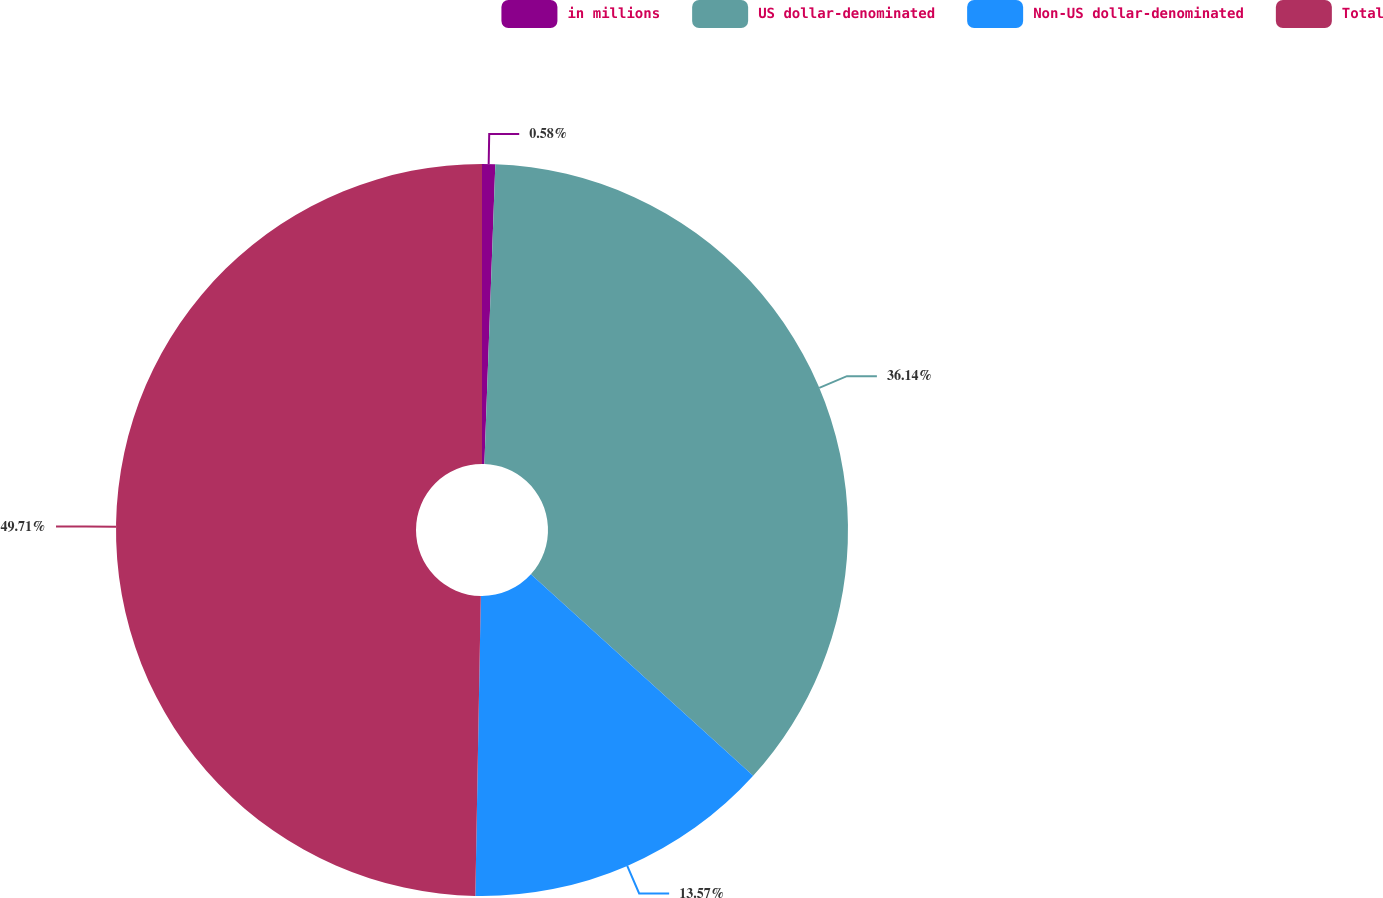Convert chart to OTSL. <chart><loc_0><loc_0><loc_500><loc_500><pie_chart><fcel>in millions<fcel>US dollar-denominated<fcel>Non-US dollar-denominated<fcel>Total<nl><fcel>0.58%<fcel>36.14%<fcel>13.57%<fcel>49.71%<nl></chart> 